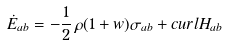<formula> <loc_0><loc_0><loc_500><loc_500>\dot { E } _ { a b } = - { \frac { 1 } { 2 } } \, \rho ( 1 + w ) \sigma _ { a b } + c u r l H _ { a b }</formula> 